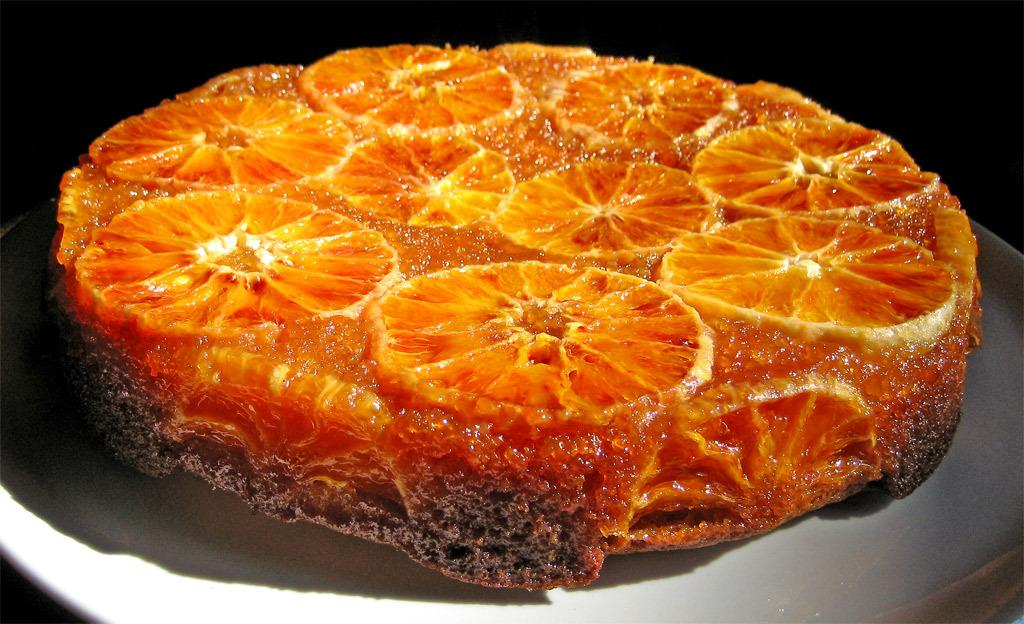What color is the food item in the image? The food item in the image is orange. What is the color of the surface on which the food item is placed? The food item is placed on a white surface. What type of food item is it? The food item appears to be a cake. What color is the background of the image? The background of the image is black. How many times does the person in the image use a hammer to break the ice? There is no person, hammer, or ice present in the image. 